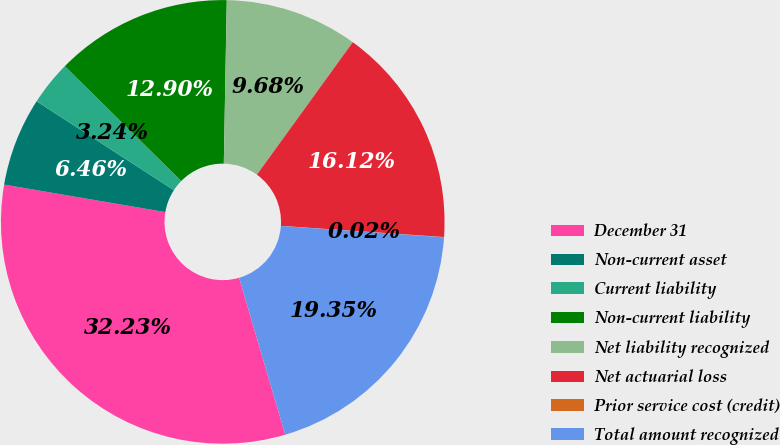Convert chart. <chart><loc_0><loc_0><loc_500><loc_500><pie_chart><fcel>December 31<fcel>Non-current asset<fcel>Current liability<fcel>Non-current liability<fcel>Net liability recognized<fcel>Net actuarial loss<fcel>Prior service cost (credit)<fcel>Total amount recognized<nl><fcel>32.23%<fcel>6.46%<fcel>3.24%<fcel>12.9%<fcel>9.68%<fcel>16.12%<fcel>0.02%<fcel>19.35%<nl></chart> 